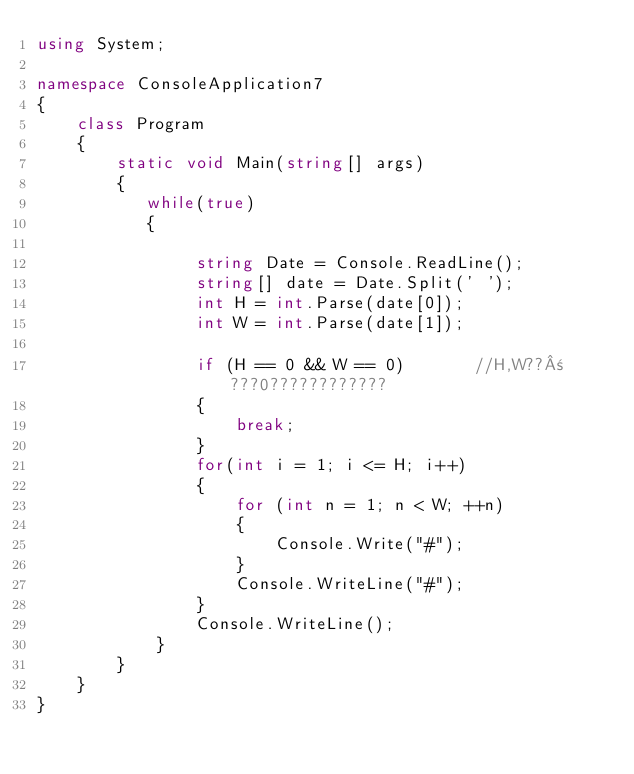Convert code to text. <code><loc_0><loc_0><loc_500><loc_500><_C#_>using System;

namespace ConsoleApplication7
{
    class Program
    {
        static void Main(string[] args)
        {
           while(true)
           {

                string Date = Console.ReadLine();
                string[] date = Date.Split(' ');
                int H = int.Parse(date[0]);
                int W = int.Parse(date[1]);

                if (H == 0 && W == 0)       //H,W??±???0????????????
                {
                    break;
                }
                for(int i = 1; i <= H; i++)
                {
                    for (int n = 1; n < W; ++n)
                    {
                        Console.Write("#");
                    }
                    Console.WriteLine("#");
                }
                Console.WriteLine();
            }
        }
    }
}</code> 